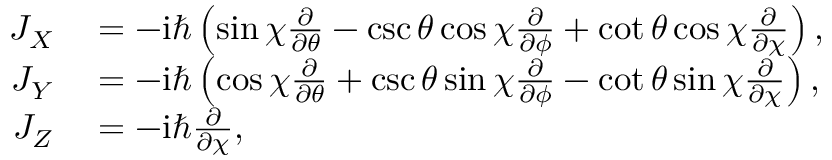<formula> <loc_0><loc_0><loc_500><loc_500>\begin{array} { r l } { J _ { X } } & = - i \hbar { \left } ( \sin \chi \frac { \partial } { \partial \theta } - \csc \theta \cos \chi \frac { \partial } { \partial \phi } + \cot \theta \cos \chi \frac { \partial } { \partial \chi } \right ) , } \\ { J _ { Y } } & = - i \hbar { \left } ( \cos \chi \frac { \partial } { \partial \theta } + \csc \theta \sin \chi \frac { \partial } { \partial \phi } - \cot \theta \sin \chi \frac { \partial } { \partial \chi } \right ) , } \\ { J _ { Z } } & = - i \hbar { } \partial } { \partial \chi } , } \end{array}</formula> 